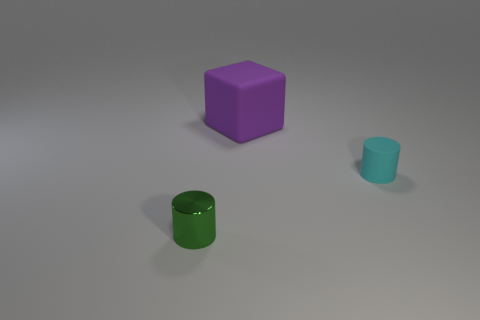Add 1 matte cubes. How many objects exist? 4 Subtract all cyan cylinders. How many cylinders are left? 1 Subtract all cylinders. How many objects are left? 1 Subtract 1 cylinders. How many cylinders are left? 1 Add 1 green metallic balls. How many green metallic balls exist? 1 Subtract 0 red cylinders. How many objects are left? 3 Subtract all green cylinders. Subtract all green balls. How many cylinders are left? 1 Subtract all cyan blocks. How many gray cylinders are left? 0 Subtract all red cylinders. Subtract all rubber cylinders. How many objects are left? 2 Add 3 cyan cylinders. How many cyan cylinders are left? 4 